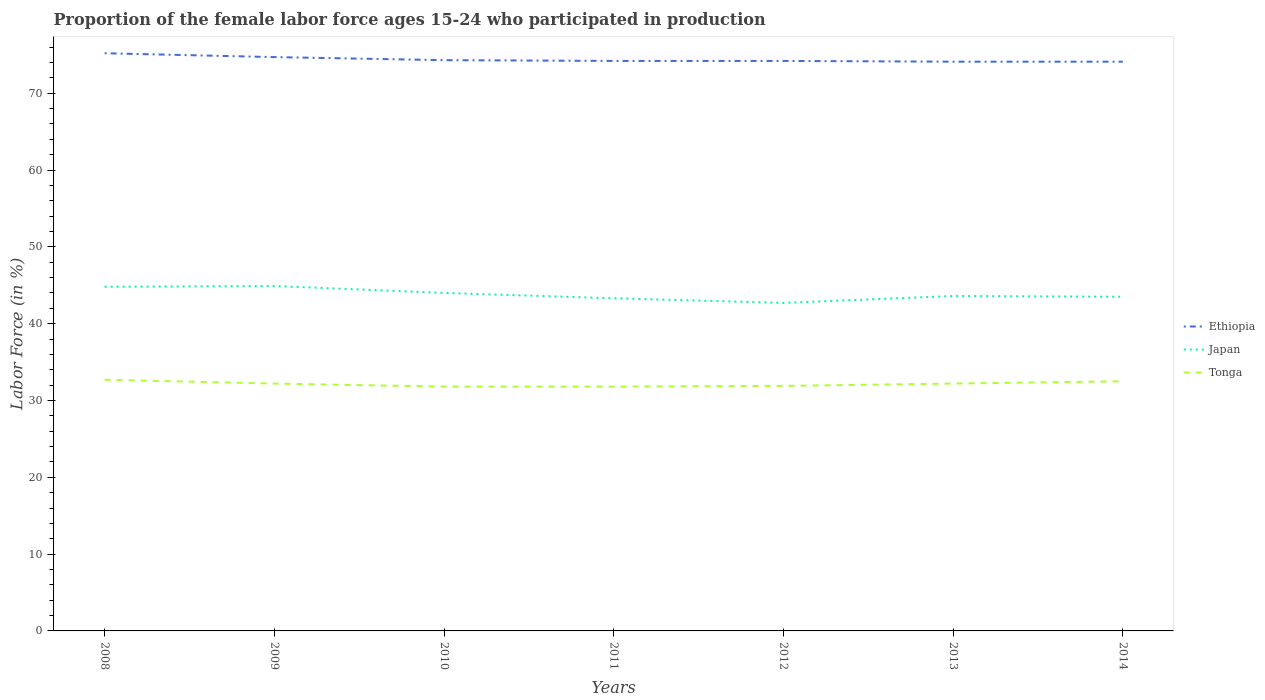How many different coloured lines are there?
Offer a very short reply. 3. Does the line corresponding to Ethiopia intersect with the line corresponding to Japan?
Make the answer very short. No. Is the number of lines equal to the number of legend labels?
Provide a succinct answer. Yes. Across all years, what is the maximum proportion of the female labor force who participated in production in Tonga?
Offer a very short reply. 31.8. In which year was the proportion of the female labor force who participated in production in Ethiopia maximum?
Make the answer very short. 2013. What is the total proportion of the female labor force who participated in production in Tonga in the graph?
Keep it short and to the point. 0.2. What is the difference between the highest and the second highest proportion of the female labor force who participated in production in Tonga?
Your answer should be compact. 0.9. Is the proportion of the female labor force who participated in production in Ethiopia strictly greater than the proportion of the female labor force who participated in production in Japan over the years?
Your answer should be compact. No. How many lines are there?
Your answer should be compact. 3. How many years are there in the graph?
Give a very brief answer. 7. What is the difference between two consecutive major ticks on the Y-axis?
Provide a short and direct response. 10. Does the graph contain grids?
Offer a very short reply. No. Where does the legend appear in the graph?
Make the answer very short. Center right. How are the legend labels stacked?
Ensure brevity in your answer.  Vertical. What is the title of the graph?
Offer a terse response. Proportion of the female labor force ages 15-24 who participated in production. What is the label or title of the X-axis?
Provide a succinct answer. Years. What is the Labor Force (in %) in Ethiopia in 2008?
Keep it short and to the point. 75.2. What is the Labor Force (in %) of Japan in 2008?
Ensure brevity in your answer.  44.8. What is the Labor Force (in %) of Tonga in 2008?
Your answer should be compact. 32.7. What is the Labor Force (in %) in Ethiopia in 2009?
Provide a short and direct response. 74.7. What is the Labor Force (in %) in Japan in 2009?
Offer a very short reply. 44.9. What is the Labor Force (in %) of Tonga in 2009?
Ensure brevity in your answer.  32.2. What is the Labor Force (in %) in Ethiopia in 2010?
Provide a succinct answer. 74.3. What is the Labor Force (in %) in Tonga in 2010?
Your answer should be compact. 31.8. What is the Labor Force (in %) of Ethiopia in 2011?
Provide a short and direct response. 74.2. What is the Labor Force (in %) in Japan in 2011?
Your answer should be very brief. 43.3. What is the Labor Force (in %) of Tonga in 2011?
Your response must be concise. 31.8. What is the Labor Force (in %) of Ethiopia in 2012?
Your answer should be very brief. 74.2. What is the Labor Force (in %) in Japan in 2012?
Offer a terse response. 42.7. What is the Labor Force (in %) in Tonga in 2012?
Your answer should be very brief. 31.9. What is the Labor Force (in %) of Ethiopia in 2013?
Give a very brief answer. 74.1. What is the Labor Force (in %) in Japan in 2013?
Offer a very short reply. 43.6. What is the Labor Force (in %) of Tonga in 2013?
Your answer should be compact. 32.2. What is the Labor Force (in %) of Ethiopia in 2014?
Make the answer very short. 74.1. What is the Labor Force (in %) in Japan in 2014?
Provide a succinct answer. 43.5. What is the Labor Force (in %) of Tonga in 2014?
Your response must be concise. 32.5. Across all years, what is the maximum Labor Force (in %) of Ethiopia?
Your answer should be compact. 75.2. Across all years, what is the maximum Labor Force (in %) of Japan?
Your response must be concise. 44.9. Across all years, what is the maximum Labor Force (in %) of Tonga?
Make the answer very short. 32.7. Across all years, what is the minimum Labor Force (in %) of Ethiopia?
Your response must be concise. 74.1. Across all years, what is the minimum Labor Force (in %) of Japan?
Ensure brevity in your answer.  42.7. Across all years, what is the minimum Labor Force (in %) of Tonga?
Give a very brief answer. 31.8. What is the total Labor Force (in %) in Ethiopia in the graph?
Keep it short and to the point. 520.8. What is the total Labor Force (in %) of Japan in the graph?
Your answer should be compact. 306.8. What is the total Labor Force (in %) in Tonga in the graph?
Provide a succinct answer. 225.1. What is the difference between the Labor Force (in %) in Japan in 2008 and that in 2009?
Provide a short and direct response. -0.1. What is the difference between the Labor Force (in %) of Tonga in 2008 and that in 2010?
Offer a very short reply. 0.9. What is the difference between the Labor Force (in %) in Ethiopia in 2008 and that in 2012?
Your answer should be compact. 1. What is the difference between the Labor Force (in %) of Tonga in 2008 and that in 2012?
Give a very brief answer. 0.8. What is the difference between the Labor Force (in %) in Ethiopia in 2008 and that in 2013?
Provide a short and direct response. 1.1. What is the difference between the Labor Force (in %) in Japan in 2008 and that in 2013?
Your answer should be very brief. 1.2. What is the difference between the Labor Force (in %) of Ethiopia in 2008 and that in 2014?
Ensure brevity in your answer.  1.1. What is the difference between the Labor Force (in %) of Ethiopia in 2009 and that in 2010?
Offer a very short reply. 0.4. What is the difference between the Labor Force (in %) in Japan in 2009 and that in 2010?
Ensure brevity in your answer.  0.9. What is the difference between the Labor Force (in %) of Ethiopia in 2009 and that in 2011?
Make the answer very short. 0.5. What is the difference between the Labor Force (in %) in Japan in 2009 and that in 2011?
Provide a succinct answer. 1.6. What is the difference between the Labor Force (in %) in Ethiopia in 2009 and that in 2012?
Your response must be concise. 0.5. What is the difference between the Labor Force (in %) in Japan in 2009 and that in 2013?
Your answer should be very brief. 1.3. What is the difference between the Labor Force (in %) in Tonga in 2009 and that in 2013?
Provide a succinct answer. 0. What is the difference between the Labor Force (in %) in Ethiopia in 2009 and that in 2014?
Your answer should be very brief. 0.6. What is the difference between the Labor Force (in %) in Tonga in 2010 and that in 2011?
Your response must be concise. 0. What is the difference between the Labor Force (in %) of Ethiopia in 2010 and that in 2012?
Your response must be concise. 0.1. What is the difference between the Labor Force (in %) in Japan in 2010 and that in 2012?
Keep it short and to the point. 1.3. What is the difference between the Labor Force (in %) in Tonga in 2010 and that in 2012?
Provide a short and direct response. -0.1. What is the difference between the Labor Force (in %) of Tonga in 2010 and that in 2014?
Ensure brevity in your answer.  -0.7. What is the difference between the Labor Force (in %) in Ethiopia in 2011 and that in 2012?
Provide a short and direct response. 0. What is the difference between the Labor Force (in %) in Japan in 2011 and that in 2012?
Offer a very short reply. 0.6. What is the difference between the Labor Force (in %) in Japan in 2011 and that in 2013?
Your response must be concise. -0.3. What is the difference between the Labor Force (in %) in Tonga in 2011 and that in 2013?
Provide a short and direct response. -0.4. What is the difference between the Labor Force (in %) of Ethiopia in 2011 and that in 2014?
Your answer should be very brief. 0.1. What is the difference between the Labor Force (in %) in Tonga in 2011 and that in 2014?
Offer a very short reply. -0.7. What is the difference between the Labor Force (in %) of Ethiopia in 2012 and that in 2014?
Offer a terse response. 0.1. What is the difference between the Labor Force (in %) in Japan in 2012 and that in 2014?
Offer a terse response. -0.8. What is the difference between the Labor Force (in %) of Tonga in 2012 and that in 2014?
Offer a terse response. -0.6. What is the difference between the Labor Force (in %) of Ethiopia in 2008 and the Labor Force (in %) of Japan in 2009?
Your response must be concise. 30.3. What is the difference between the Labor Force (in %) in Ethiopia in 2008 and the Labor Force (in %) in Tonga in 2009?
Offer a very short reply. 43. What is the difference between the Labor Force (in %) in Ethiopia in 2008 and the Labor Force (in %) in Japan in 2010?
Make the answer very short. 31.2. What is the difference between the Labor Force (in %) of Ethiopia in 2008 and the Labor Force (in %) of Tonga in 2010?
Ensure brevity in your answer.  43.4. What is the difference between the Labor Force (in %) of Japan in 2008 and the Labor Force (in %) of Tonga in 2010?
Give a very brief answer. 13. What is the difference between the Labor Force (in %) in Ethiopia in 2008 and the Labor Force (in %) in Japan in 2011?
Provide a short and direct response. 31.9. What is the difference between the Labor Force (in %) in Ethiopia in 2008 and the Labor Force (in %) in Tonga in 2011?
Your answer should be very brief. 43.4. What is the difference between the Labor Force (in %) of Japan in 2008 and the Labor Force (in %) of Tonga in 2011?
Provide a succinct answer. 13. What is the difference between the Labor Force (in %) in Ethiopia in 2008 and the Labor Force (in %) in Japan in 2012?
Give a very brief answer. 32.5. What is the difference between the Labor Force (in %) in Ethiopia in 2008 and the Labor Force (in %) in Tonga in 2012?
Your response must be concise. 43.3. What is the difference between the Labor Force (in %) of Ethiopia in 2008 and the Labor Force (in %) of Japan in 2013?
Your answer should be compact. 31.6. What is the difference between the Labor Force (in %) in Ethiopia in 2008 and the Labor Force (in %) in Tonga in 2013?
Give a very brief answer. 43. What is the difference between the Labor Force (in %) in Ethiopia in 2008 and the Labor Force (in %) in Japan in 2014?
Keep it short and to the point. 31.7. What is the difference between the Labor Force (in %) of Ethiopia in 2008 and the Labor Force (in %) of Tonga in 2014?
Keep it short and to the point. 42.7. What is the difference between the Labor Force (in %) of Japan in 2008 and the Labor Force (in %) of Tonga in 2014?
Make the answer very short. 12.3. What is the difference between the Labor Force (in %) of Ethiopia in 2009 and the Labor Force (in %) of Japan in 2010?
Ensure brevity in your answer.  30.7. What is the difference between the Labor Force (in %) in Ethiopia in 2009 and the Labor Force (in %) in Tonga in 2010?
Offer a terse response. 42.9. What is the difference between the Labor Force (in %) of Ethiopia in 2009 and the Labor Force (in %) of Japan in 2011?
Your answer should be compact. 31.4. What is the difference between the Labor Force (in %) of Ethiopia in 2009 and the Labor Force (in %) of Tonga in 2011?
Make the answer very short. 42.9. What is the difference between the Labor Force (in %) in Japan in 2009 and the Labor Force (in %) in Tonga in 2011?
Provide a short and direct response. 13.1. What is the difference between the Labor Force (in %) in Ethiopia in 2009 and the Labor Force (in %) in Tonga in 2012?
Ensure brevity in your answer.  42.8. What is the difference between the Labor Force (in %) of Ethiopia in 2009 and the Labor Force (in %) of Japan in 2013?
Keep it short and to the point. 31.1. What is the difference between the Labor Force (in %) in Ethiopia in 2009 and the Labor Force (in %) in Tonga in 2013?
Make the answer very short. 42.5. What is the difference between the Labor Force (in %) of Japan in 2009 and the Labor Force (in %) of Tonga in 2013?
Provide a short and direct response. 12.7. What is the difference between the Labor Force (in %) of Ethiopia in 2009 and the Labor Force (in %) of Japan in 2014?
Offer a very short reply. 31.2. What is the difference between the Labor Force (in %) of Ethiopia in 2009 and the Labor Force (in %) of Tonga in 2014?
Your answer should be compact. 42.2. What is the difference between the Labor Force (in %) in Japan in 2009 and the Labor Force (in %) in Tonga in 2014?
Your response must be concise. 12.4. What is the difference between the Labor Force (in %) in Ethiopia in 2010 and the Labor Force (in %) in Tonga in 2011?
Keep it short and to the point. 42.5. What is the difference between the Labor Force (in %) in Ethiopia in 2010 and the Labor Force (in %) in Japan in 2012?
Provide a short and direct response. 31.6. What is the difference between the Labor Force (in %) in Ethiopia in 2010 and the Labor Force (in %) in Tonga in 2012?
Make the answer very short. 42.4. What is the difference between the Labor Force (in %) in Japan in 2010 and the Labor Force (in %) in Tonga in 2012?
Provide a short and direct response. 12.1. What is the difference between the Labor Force (in %) of Ethiopia in 2010 and the Labor Force (in %) of Japan in 2013?
Offer a terse response. 30.7. What is the difference between the Labor Force (in %) of Ethiopia in 2010 and the Labor Force (in %) of Tonga in 2013?
Provide a short and direct response. 42.1. What is the difference between the Labor Force (in %) in Japan in 2010 and the Labor Force (in %) in Tonga in 2013?
Your answer should be compact. 11.8. What is the difference between the Labor Force (in %) in Ethiopia in 2010 and the Labor Force (in %) in Japan in 2014?
Make the answer very short. 30.8. What is the difference between the Labor Force (in %) in Ethiopia in 2010 and the Labor Force (in %) in Tonga in 2014?
Your response must be concise. 41.8. What is the difference between the Labor Force (in %) of Ethiopia in 2011 and the Labor Force (in %) of Japan in 2012?
Make the answer very short. 31.5. What is the difference between the Labor Force (in %) of Ethiopia in 2011 and the Labor Force (in %) of Tonga in 2012?
Give a very brief answer. 42.3. What is the difference between the Labor Force (in %) in Ethiopia in 2011 and the Labor Force (in %) in Japan in 2013?
Keep it short and to the point. 30.6. What is the difference between the Labor Force (in %) of Ethiopia in 2011 and the Labor Force (in %) of Tonga in 2013?
Make the answer very short. 42. What is the difference between the Labor Force (in %) in Japan in 2011 and the Labor Force (in %) in Tonga in 2013?
Offer a terse response. 11.1. What is the difference between the Labor Force (in %) in Ethiopia in 2011 and the Labor Force (in %) in Japan in 2014?
Offer a terse response. 30.7. What is the difference between the Labor Force (in %) of Ethiopia in 2011 and the Labor Force (in %) of Tonga in 2014?
Ensure brevity in your answer.  41.7. What is the difference between the Labor Force (in %) in Japan in 2011 and the Labor Force (in %) in Tonga in 2014?
Your response must be concise. 10.8. What is the difference between the Labor Force (in %) of Ethiopia in 2012 and the Labor Force (in %) of Japan in 2013?
Your answer should be very brief. 30.6. What is the difference between the Labor Force (in %) of Japan in 2012 and the Labor Force (in %) of Tonga in 2013?
Your answer should be compact. 10.5. What is the difference between the Labor Force (in %) of Ethiopia in 2012 and the Labor Force (in %) of Japan in 2014?
Keep it short and to the point. 30.7. What is the difference between the Labor Force (in %) of Ethiopia in 2012 and the Labor Force (in %) of Tonga in 2014?
Your answer should be compact. 41.7. What is the difference between the Labor Force (in %) in Japan in 2012 and the Labor Force (in %) in Tonga in 2014?
Make the answer very short. 10.2. What is the difference between the Labor Force (in %) in Ethiopia in 2013 and the Labor Force (in %) in Japan in 2014?
Make the answer very short. 30.6. What is the difference between the Labor Force (in %) of Ethiopia in 2013 and the Labor Force (in %) of Tonga in 2014?
Keep it short and to the point. 41.6. What is the difference between the Labor Force (in %) of Japan in 2013 and the Labor Force (in %) of Tonga in 2014?
Provide a short and direct response. 11.1. What is the average Labor Force (in %) of Ethiopia per year?
Offer a very short reply. 74.4. What is the average Labor Force (in %) of Japan per year?
Provide a short and direct response. 43.83. What is the average Labor Force (in %) of Tonga per year?
Offer a very short reply. 32.16. In the year 2008, what is the difference between the Labor Force (in %) in Ethiopia and Labor Force (in %) in Japan?
Give a very brief answer. 30.4. In the year 2008, what is the difference between the Labor Force (in %) of Ethiopia and Labor Force (in %) of Tonga?
Offer a terse response. 42.5. In the year 2008, what is the difference between the Labor Force (in %) of Japan and Labor Force (in %) of Tonga?
Offer a terse response. 12.1. In the year 2009, what is the difference between the Labor Force (in %) of Ethiopia and Labor Force (in %) of Japan?
Give a very brief answer. 29.8. In the year 2009, what is the difference between the Labor Force (in %) in Ethiopia and Labor Force (in %) in Tonga?
Your answer should be very brief. 42.5. In the year 2010, what is the difference between the Labor Force (in %) of Ethiopia and Labor Force (in %) of Japan?
Your response must be concise. 30.3. In the year 2010, what is the difference between the Labor Force (in %) of Ethiopia and Labor Force (in %) of Tonga?
Provide a short and direct response. 42.5. In the year 2011, what is the difference between the Labor Force (in %) in Ethiopia and Labor Force (in %) in Japan?
Your answer should be compact. 30.9. In the year 2011, what is the difference between the Labor Force (in %) in Ethiopia and Labor Force (in %) in Tonga?
Give a very brief answer. 42.4. In the year 2012, what is the difference between the Labor Force (in %) of Ethiopia and Labor Force (in %) of Japan?
Provide a succinct answer. 31.5. In the year 2012, what is the difference between the Labor Force (in %) of Ethiopia and Labor Force (in %) of Tonga?
Provide a short and direct response. 42.3. In the year 2013, what is the difference between the Labor Force (in %) of Ethiopia and Labor Force (in %) of Japan?
Offer a very short reply. 30.5. In the year 2013, what is the difference between the Labor Force (in %) in Ethiopia and Labor Force (in %) in Tonga?
Your answer should be very brief. 41.9. In the year 2013, what is the difference between the Labor Force (in %) in Japan and Labor Force (in %) in Tonga?
Provide a succinct answer. 11.4. In the year 2014, what is the difference between the Labor Force (in %) of Ethiopia and Labor Force (in %) of Japan?
Keep it short and to the point. 30.6. In the year 2014, what is the difference between the Labor Force (in %) of Ethiopia and Labor Force (in %) of Tonga?
Your answer should be very brief. 41.6. In the year 2014, what is the difference between the Labor Force (in %) in Japan and Labor Force (in %) in Tonga?
Your response must be concise. 11. What is the ratio of the Labor Force (in %) of Tonga in 2008 to that in 2009?
Offer a very short reply. 1.02. What is the ratio of the Labor Force (in %) of Ethiopia in 2008 to that in 2010?
Provide a short and direct response. 1.01. What is the ratio of the Labor Force (in %) in Japan in 2008 to that in 2010?
Make the answer very short. 1.02. What is the ratio of the Labor Force (in %) in Tonga in 2008 to that in 2010?
Offer a terse response. 1.03. What is the ratio of the Labor Force (in %) of Ethiopia in 2008 to that in 2011?
Your answer should be compact. 1.01. What is the ratio of the Labor Force (in %) of Japan in 2008 to that in 2011?
Ensure brevity in your answer.  1.03. What is the ratio of the Labor Force (in %) in Tonga in 2008 to that in 2011?
Your answer should be very brief. 1.03. What is the ratio of the Labor Force (in %) of Ethiopia in 2008 to that in 2012?
Your answer should be compact. 1.01. What is the ratio of the Labor Force (in %) in Japan in 2008 to that in 2012?
Your response must be concise. 1.05. What is the ratio of the Labor Force (in %) of Tonga in 2008 to that in 2012?
Your answer should be compact. 1.03. What is the ratio of the Labor Force (in %) of Ethiopia in 2008 to that in 2013?
Give a very brief answer. 1.01. What is the ratio of the Labor Force (in %) in Japan in 2008 to that in 2013?
Provide a succinct answer. 1.03. What is the ratio of the Labor Force (in %) in Tonga in 2008 to that in 2013?
Keep it short and to the point. 1.02. What is the ratio of the Labor Force (in %) in Ethiopia in 2008 to that in 2014?
Make the answer very short. 1.01. What is the ratio of the Labor Force (in %) of Japan in 2008 to that in 2014?
Offer a very short reply. 1.03. What is the ratio of the Labor Force (in %) of Tonga in 2008 to that in 2014?
Give a very brief answer. 1.01. What is the ratio of the Labor Force (in %) of Ethiopia in 2009 to that in 2010?
Your response must be concise. 1.01. What is the ratio of the Labor Force (in %) in Japan in 2009 to that in 2010?
Your response must be concise. 1.02. What is the ratio of the Labor Force (in %) of Tonga in 2009 to that in 2010?
Your answer should be very brief. 1.01. What is the ratio of the Labor Force (in %) in Japan in 2009 to that in 2011?
Your response must be concise. 1.04. What is the ratio of the Labor Force (in %) of Tonga in 2009 to that in 2011?
Offer a very short reply. 1.01. What is the ratio of the Labor Force (in %) in Ethiopia in 2009 to that in 2012?
Offer a very short reply. 1.01. What is the ratio of the Labor Force (in %) of Japan in 2009 to that in 2012?
Your response must be concise. 1.05. What is the ratio of the Labor Force (in %) in Tonga in 2009 to that in 2012?
Your answer should be compact. 1.01. What is the ratio of the Labor Force (in %) of Ethiopia in 2009 to that in 2013?
Your answer should be very brief. 1.01. What is the ratio of the Labor Force (in %) in Japan in 2009 to that in 2013?
Your answer should be very brief. 1.03. What is the ratio of the Labor Force (in %) of Japan in 2009 to that in 2014?
Your answer should be very brief. 1.03. What is the ratio of the Labor Force (in %) of Tonga in 2009 to that in 2014?
Your answer should be compact. 0.99. What is the ratio of the Labor Force (in %) of Ethiopia in 2010 to that in 2011?
Provide a succinct answer. 1. What is the ratio of the Labor Force (in %) of Japan in 2010 to that in 2011?
Provide a succinct answer. 1.02. What is the ratio of the Labor Force (in %) in Tonga in 2010 to that in 2011?
Provide a short and direct response. 1. What is the ratio of the Labor Force (in %) in Japan in 2010 to that in 2012?
Ensure brevity in your answer.  1.03. What is the ratio of the Labor Force (in %) in Tonga in 2010 to that in 2012?
Your answer should be compact. 1. What is the ratio of the Labor Force (in %) of Ethiopia in 2010 to that in 2013?
Ensure brevity in your answer.  1. What is the ratio of the Labor Force (in %) in Japan in 2010 to that in 2013?
Ensure brevity in your answer.  1.01. What is the ratio of the Labor Force (in %) in Tonga in 2010 to that in 2013?
Your answer should be very brief. 0.99. What is the ratio of the Labor Force (in %) of Japan in 2010 to that in 2014?
Provide a short and direct response. 1.01. What is the ratio of the Labor Force (in %) of Tonga in 2010 to that in 2014?
Your answer should be very brief. 0.98. What is the ratio of the Labor Force (in %) of Japan in 2011 to that in 2012?
Ensure brevity in your answer.  1.01. What is the ratio of the Labor Force (in %) in Tonga in 2011 to that in 2012?
Make the answer very short. 1. What is the ratio of the Labor Force (in %) of Tonga in 2011 to that in 2013?
Offer a terse response. 0.99. What is the ratio of the Labor Force (in %) of Japan in 2011 to that in 2014?
Give a very brief answer. 1. What is the ratio of the Labor Force (in %) of Tonga in 2011 to that in 2014?
Offer a very short reply. 0.98. What is the ratio of the Labor Force (in %) of Japan in 2012 to that in 2013?
Your answer should be very brief. 0.98. What is the ratio of the Labor Force (in %) of Tonga in 2012 to that in 2013?
Your response must be concise. 0.99. What is the ratio of the Labor Force (in %) in Japan in 2012 to that in 2014?
Give a very brief answer. 0.98. What is the ratio of the Labor Force (in %) in Tonga in 2012 to that in 2014?
Keep it short and to the point. 0.98. What is the ratio of the Labor Force (in %) of Ethiopia in 2013 to that in 2014?
Your answer should be compact. 1. What is the ratio of the Labor Force (in %) in Japan in 2013 to that in 2014?
Give a very brief answer. 1. What is the difference between the highest and the lowest Labor Force (in %) of Ethiopia?
Provide a short and direct response. 1.1. 